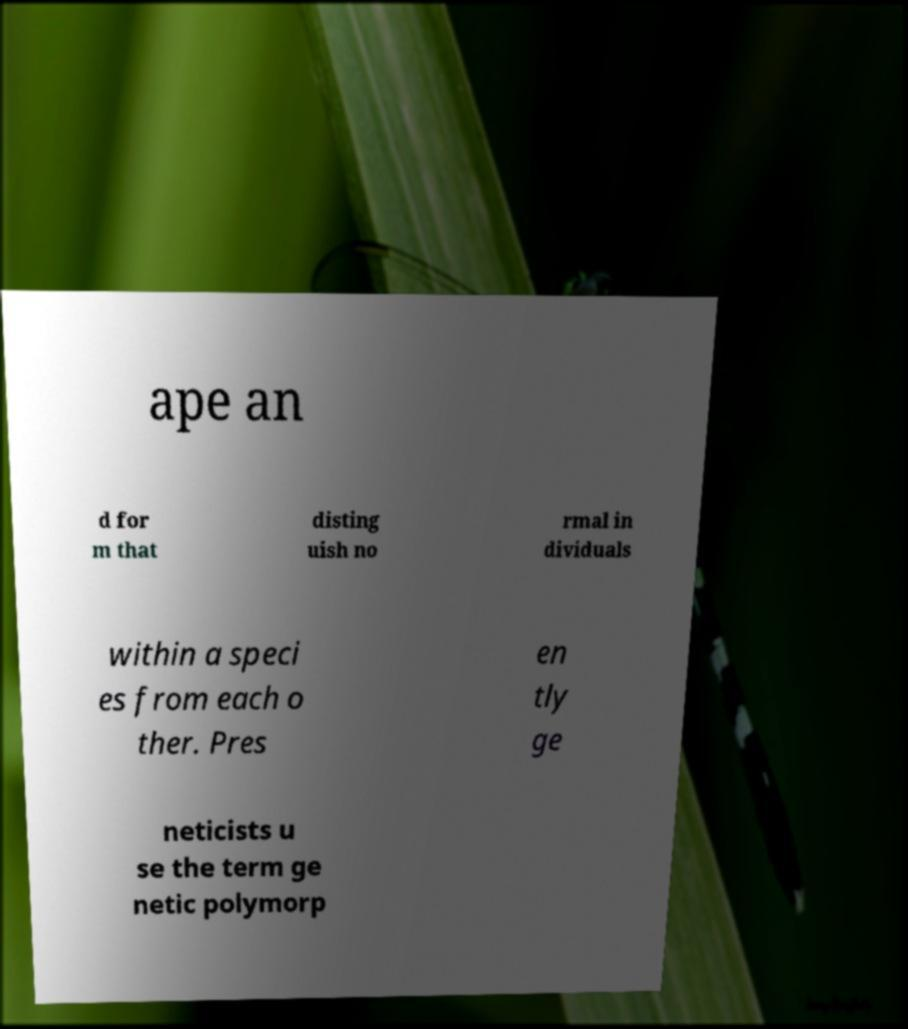I need the written content from this picture converted into text. Can you do that? ape an d for m that disting uish no rmal in dividuals within a speci es from each o ther. Pres en tly ge neticists u se the term ge netic polymorp 